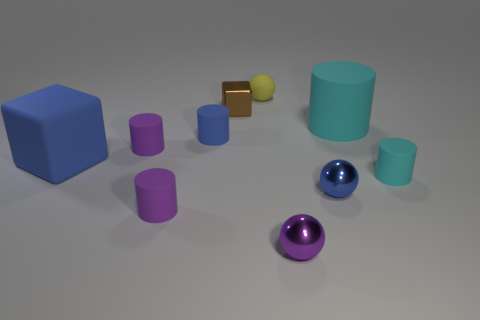The cyan matte thing that is the same size as the blue rubber block is what shape? The object you're referring to is a cylinder. Its matte cyan surface differs from the blue block's rubber texture, yet they share a similar size. The cylindrical shape is characterized by its circular base and the curved surface that extends between the bases on either end. 